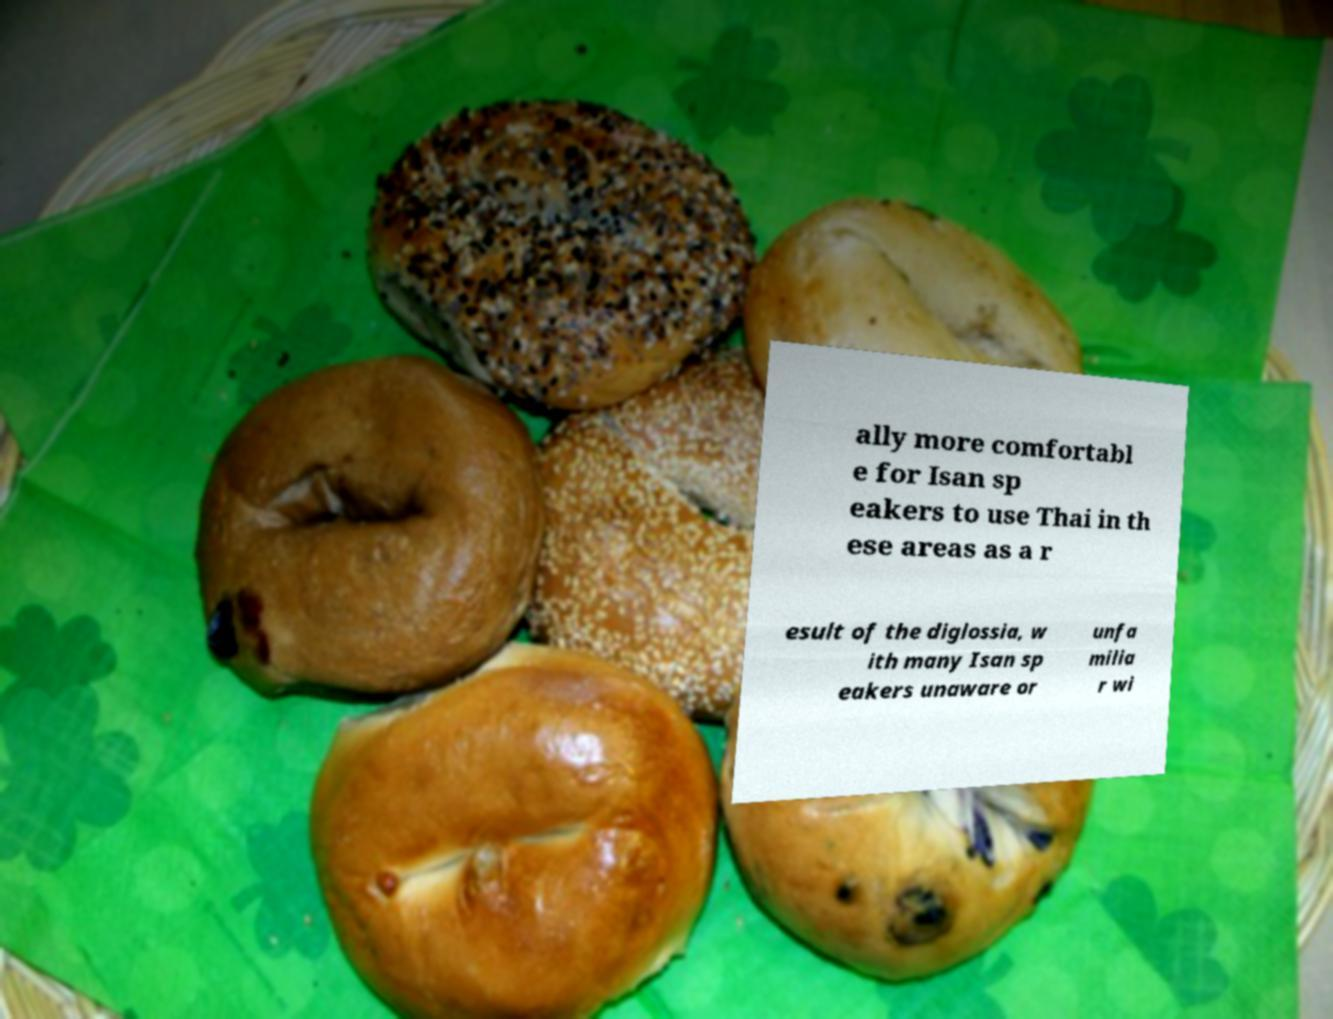There's text embedded in this image that I need extracted. Can you transcribe it verbatim? ally more comfortabl e for Isan sp eakers to use Thai in th ese areas as a r esult of the diglossia, w ith many Isan sp eakers unaware or unfa milia r wi 